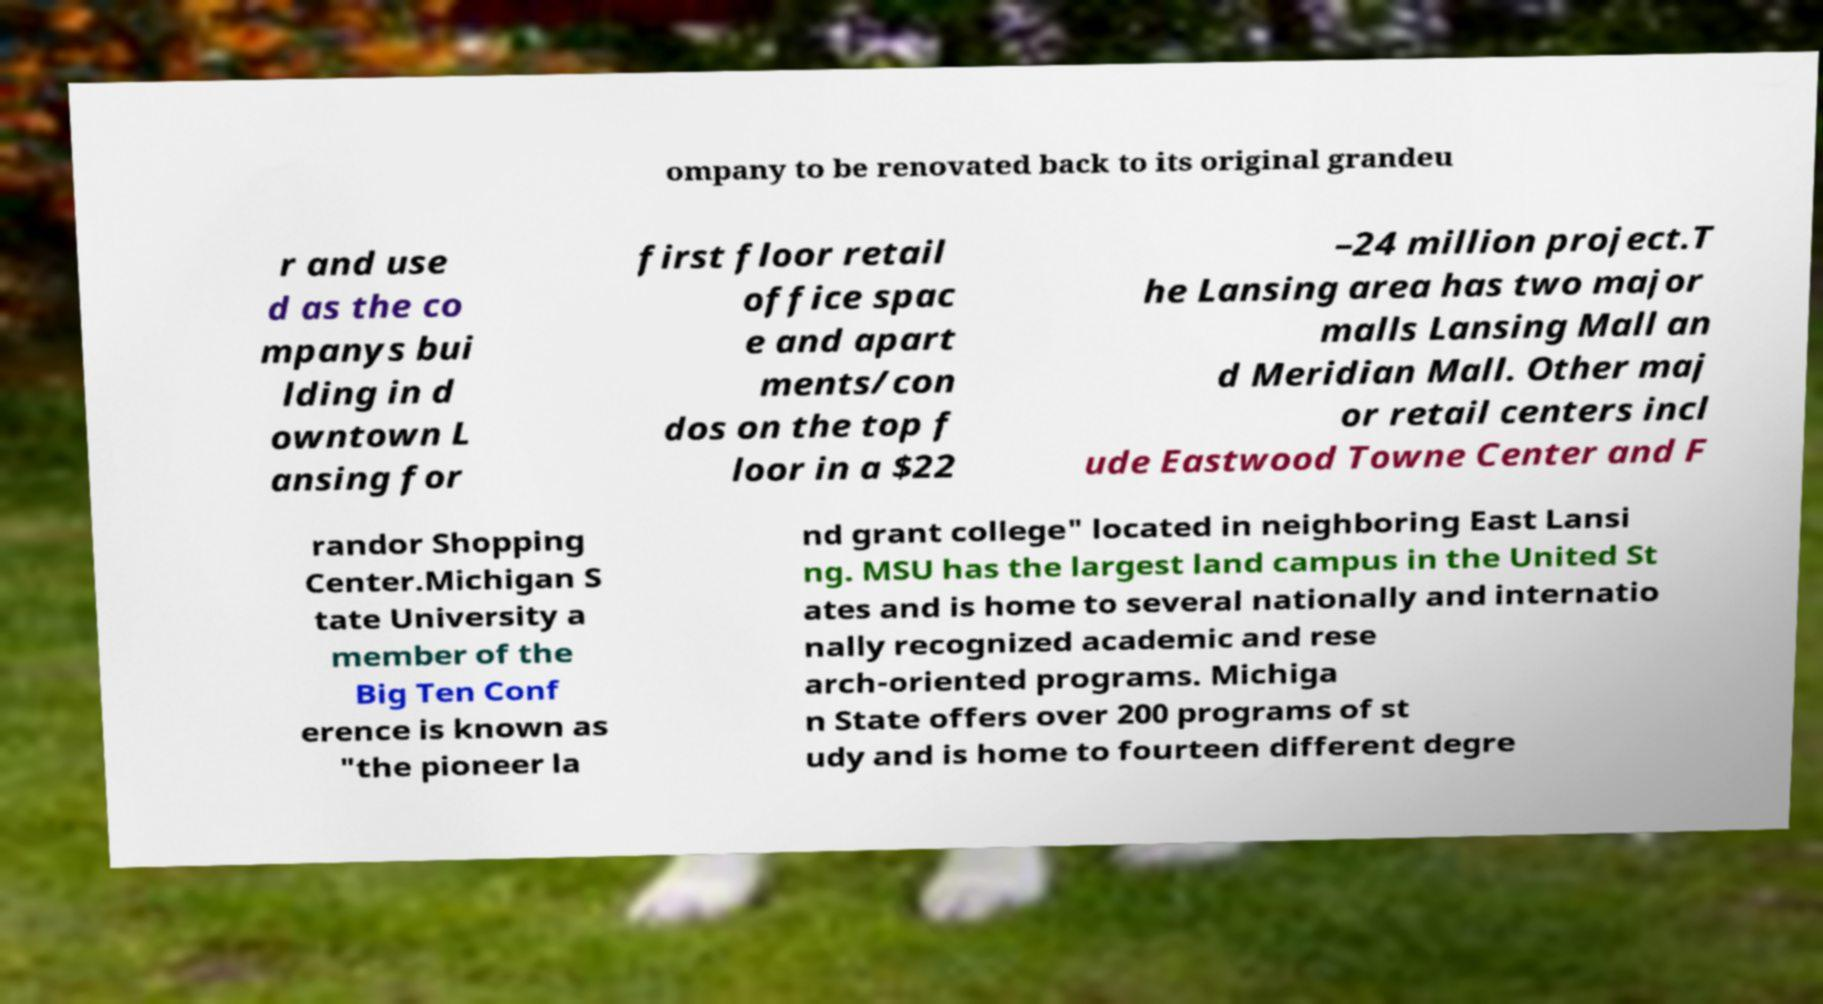Could you extract and type out the text from this image? ompany to be renovated back to its original grandeu r and use d as the co mpanys bui lding in d owntown L ansing for first floor retail office spac e and apart ments/con dos on the top f loor in a $22 –24 million project.T he Lansing area has two major malls Lansing Mall an d Meridian Mall. Other maj or retail centers incl ude Eastwood Towne Center and F randor Shopping Center.Michigan S tate University a member of the Big Ten Conf erence is known as "the pioneer la nd grant college" located in neighboring East Lansi ng. MSU has the largest land campus in the United St ates and is home to several nationally and internatio nally recognized academic and rese arch-oriented programs. Michiga n State offers over 200 programs of st udy and is home to fourteen different degre 